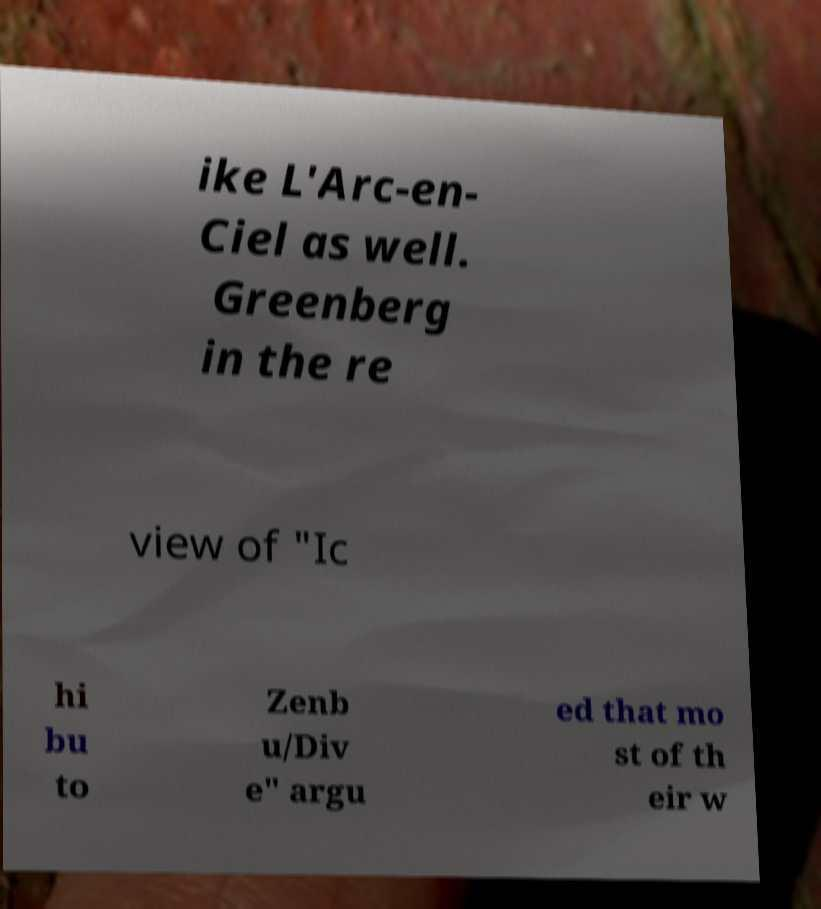There's text embedded in this image that I need extracted. Can you transcribe it verbatim? ike L'Arc-en- Ciel as well. Greenberg in the re view of "Ic hi bu to Zenb u/Div e" argu ed that mo st of th eir w 